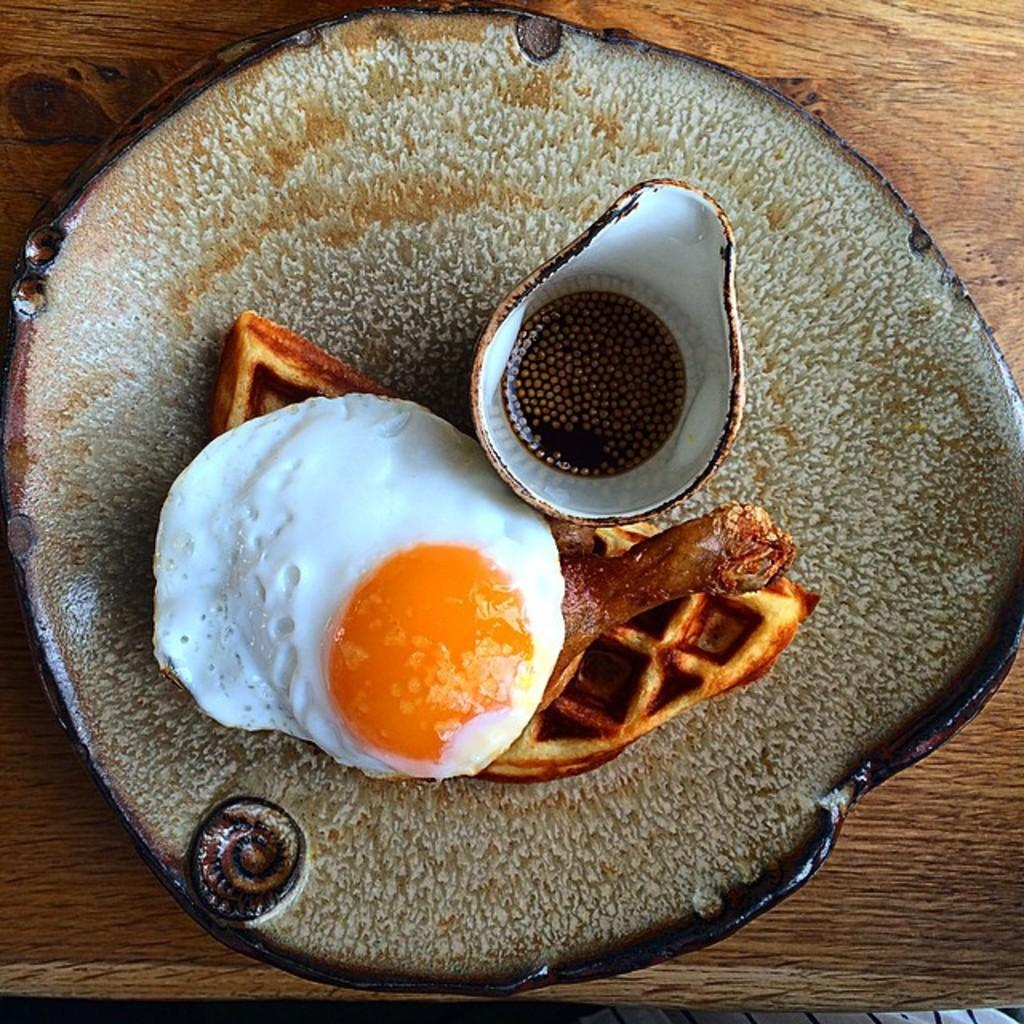What is the main food item visible in the image? There is a food item served in a plate in the image. Where is the plate placed? The plate is placed on an object. Can you describe the white color object in the image? There is a white color object at the bottom towards the right in the image. What type of connection can be seen between the food item and the white color object in the image? There is no visible connection between the food item and the white color object in the image. 